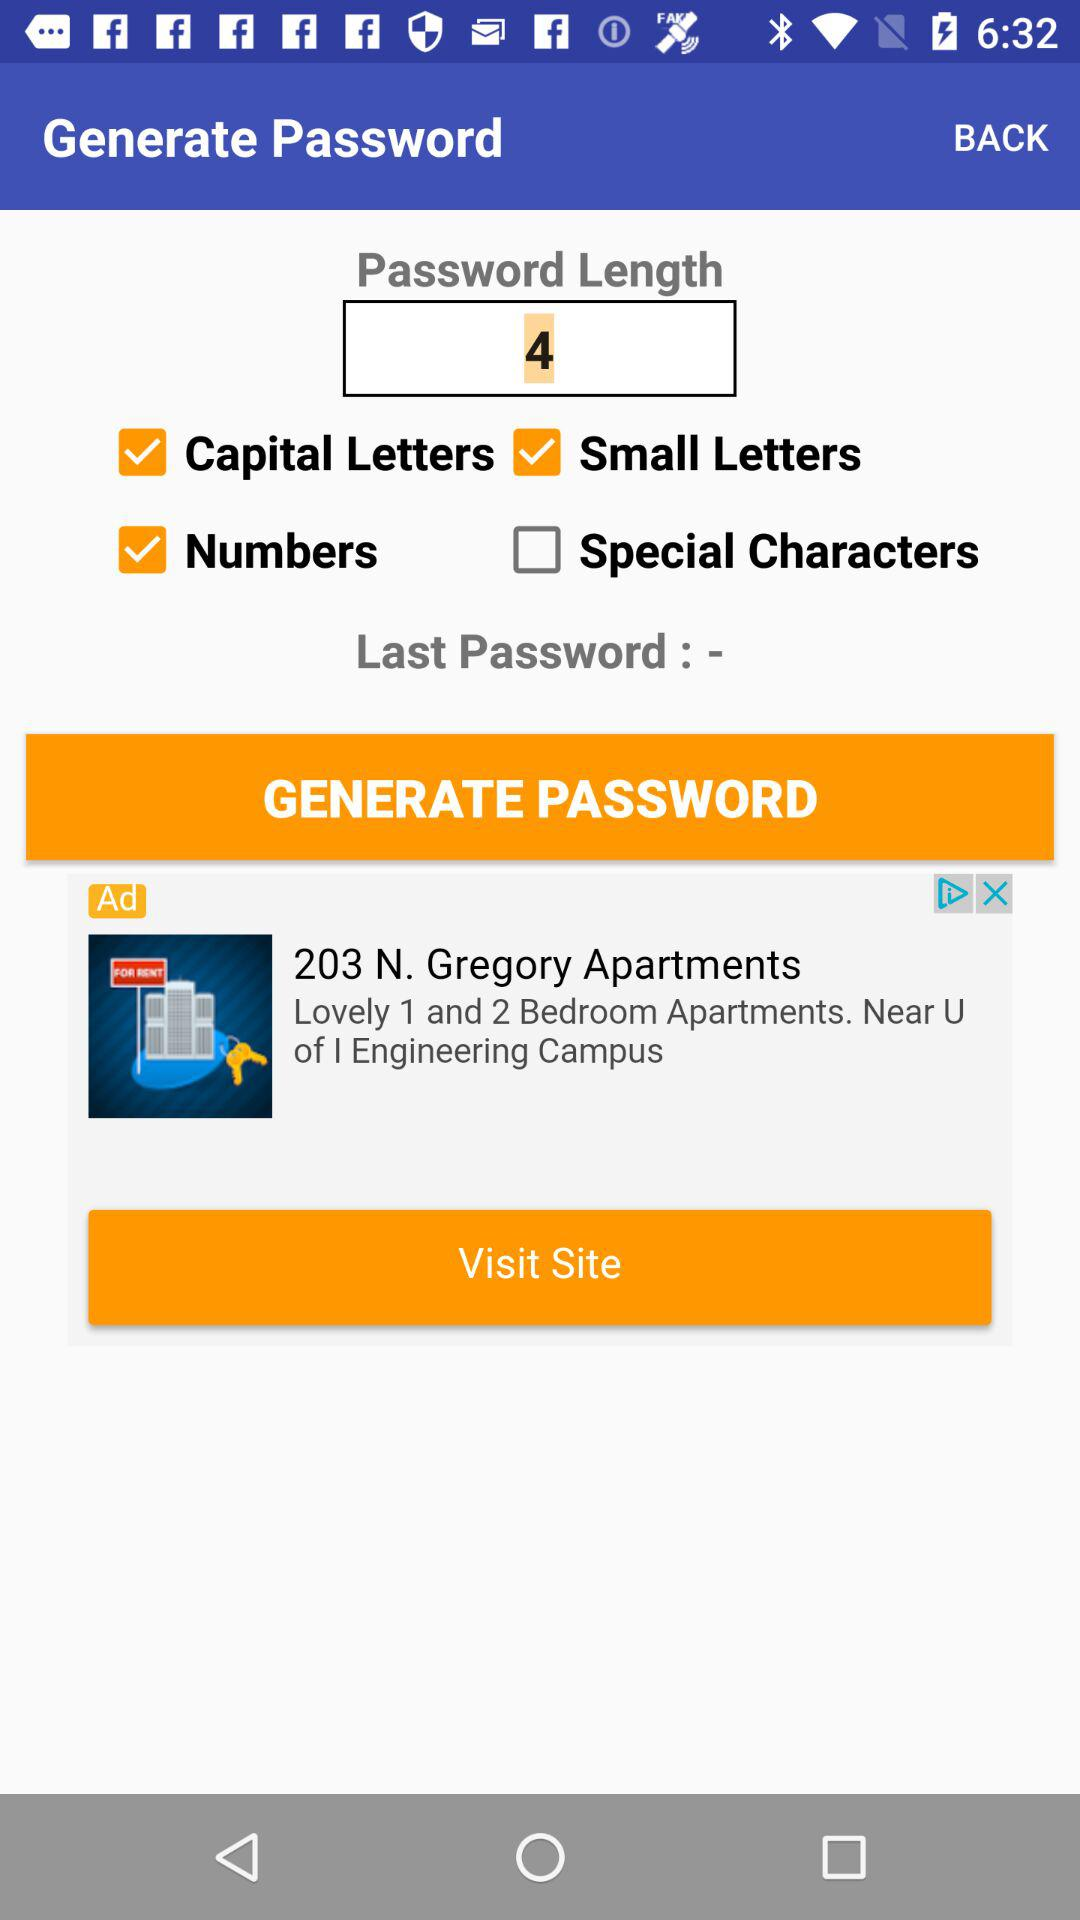What is the checked letter type? The checked letter types are "Capital Letters" and "Small Letters". 